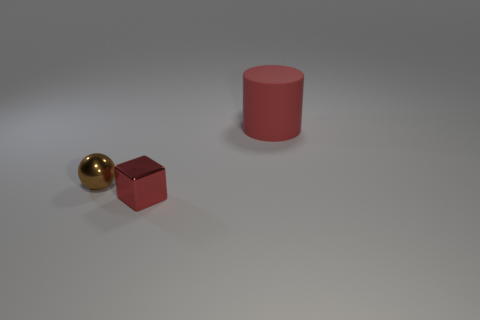Subtract all purple balls. Subtract all gray cylinders. How many balls are left? 1 Add 2 large red metal cubes. How many objects exist? 5 Subtract all spheres. How many objects are left? 2 Subtract 0 cyan spheres. How many objects are left? 3 Subtract all metallic blocks. Subtract all tiny red blocks. How many objects are left? 1 Add 2 brown metal objects. How many brown metal objects are left? 3 Add 1 tiny red rubber spheres. How many tiny red rubber spheres exist? 1 